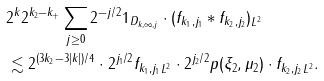Convert formula to latex. <formula><loc_0><loc_0><loc_500><loc_500>& 2 ^ { k } 2 ^ { k _ { 2 } - k _ { + } } \sum _ { j \geq 0 } 2 ^ { - j / 2 } \| 1 _ { D _ { k , \infty , j } } \cdot ( f _ { k _ { 1 } , j _ { 1 } } \ast f _ { k _ { 2 } , j _ { 2 } } ) \| _ { L ^ { 2 } } \\ & \lesssim 2 ^ { ( 3 k _ { 2 } - 3 | k | ) / 4 } \cdot 2 ^ { j _ { 1 } / 2 } \| f _ { k _ { 1 } , j _ { 1 } } \| _ { L ^ { 2 } } \cdot 2 ^ { j _ { 2 } / 2 } \| p ( \xi _ { 2 } , \mu _ { 2 } ) \cdot f _ { k _ { 2 } , j _ { 2 } } \| _ { L ^ { 2 } } .</formula> 